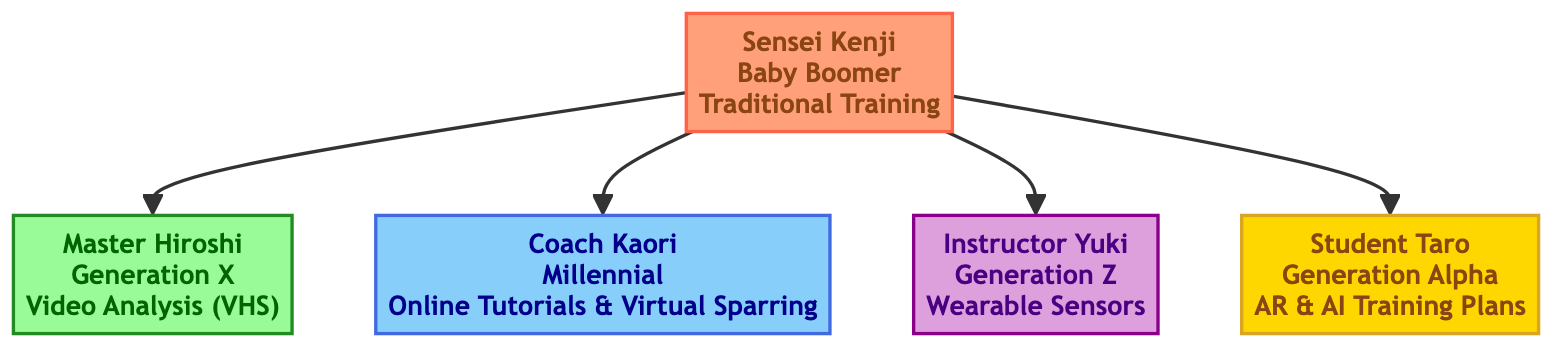What is the name of the oldest generation in the family tree? The oldest generation, as represented by the root node, is Sensei Kenji.
Answer: Sensei Kenji How many children does Sensei Kenji have? The diagram shows four direct connections from Sensei Kenji to his children, which indicates he has four children.
Answer: 4 What technology does Master Hiroshi utilize for training? The node for Master Hiroshi specifies that he uses Video Analysis for Technique Improvement (VHS).
Answer: Video Analysis (VHS) Which generation is Student Taro part of? The diagram indicates Student Taro belongs to Generation Alpha, as specified in his node.
Answer: Generation Alpha What type of technology does Instructor Yuki use? Instructor Yuki's node describes the technology he uses as Wearable Sensors for Performance Metrics (Smartwatches, Heart Rate Monitors).
Answer: Wearable Sensors Which generation incorporated Online Tutorials and Virtual Sparring Partners? Referring to the node for Coach Kaori, it confirms that she utilizes Online Tutorials and Virtual Sparring Partners, indicating that this technology is incorporated during the Millennial generation.
Answer: Millennial Which training technology shows the most advancement according to generation? By analyzing the technological progress from Sensei Kenji's traditional methods to Student Taro's use of Augmented Reality and AI-driven training plans, it's clear that Student Taro shows the most advancement in technology.
Answer: Augmented Reality and AI Training Plans How does the training technology of Generation X differ from that of Generation Z? Master Hiroshi (Generation X) uses Video Analysis, which is primarily focused on reviewing footage, whereas Instructor Yuki (Generation Z) employs Wearable Sensors, which provide real-time data on performance metrics. This illustrates a shift from retrospective analysis to real-time monitoring.
Answer: Video Analysis vs. Wearable Sensors What is the relationship between Sensei Kenji and Student Taro? The diagram shows that Sensei Kenji is the root, and Student Taro is one of his children, signifying a direct parent-child relationship.
Answer: Parent-child relationship 